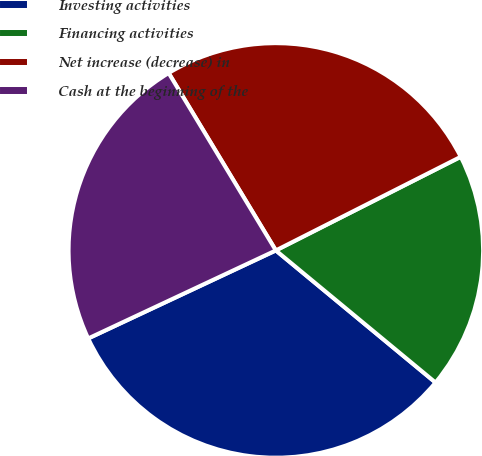<chart> <loc_0><loc_0><loc_500><loc_500><pie_chart><fcel>Investing activities<fcel>Financing activities<fcel>Net increase (decrease) in<fcel>Cash at the beginning of the<nl><fcel>32.02%<fcel>18.46%<fcel>26.19%<fcel>23.33%<nl></chart> 